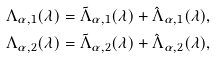<formula> <loc_0><loc_0><loc_500><loc_500>\Lambda _ { \alpha , 1 } ( \lambda ) = \tilde { \Lambda } _ { \alpha , 1 } ( \lambda ) + \hat { \Lambda } _ { \alpha , 1 } ( \lambda ) , \\ \Lambda _ { \alpha , 2 } ( \lambda ) = \tilde { \Lambda } _ { \alpha , 2 } ( \lambda ) + \hat { \Lambda } _ { \alpha , 2 } ( \lambda ) ,</formula> 